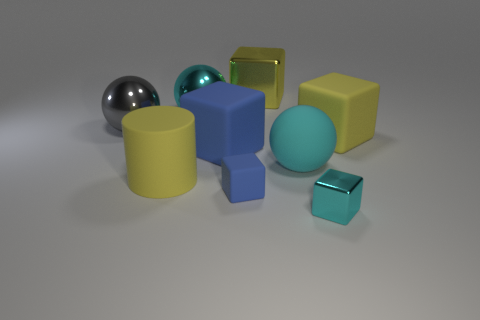Subtract all cyan cylinders. Subtract all yellow cubes. How many cylinders are left? 1 Add 1 big blue rubber cubes. How many objects exist? 10 Subtract all cylinders. How many objects are left? 8 Add 6 yellow things. How many yellow things are left? 9 Add 2 small red objects. How many small red objects exist? 2 Subtract 1 blue cubes. How many objects are left? 8 Subtract all cyan blocks. Subtract all cyan matte objects. How many objects are left? 7 